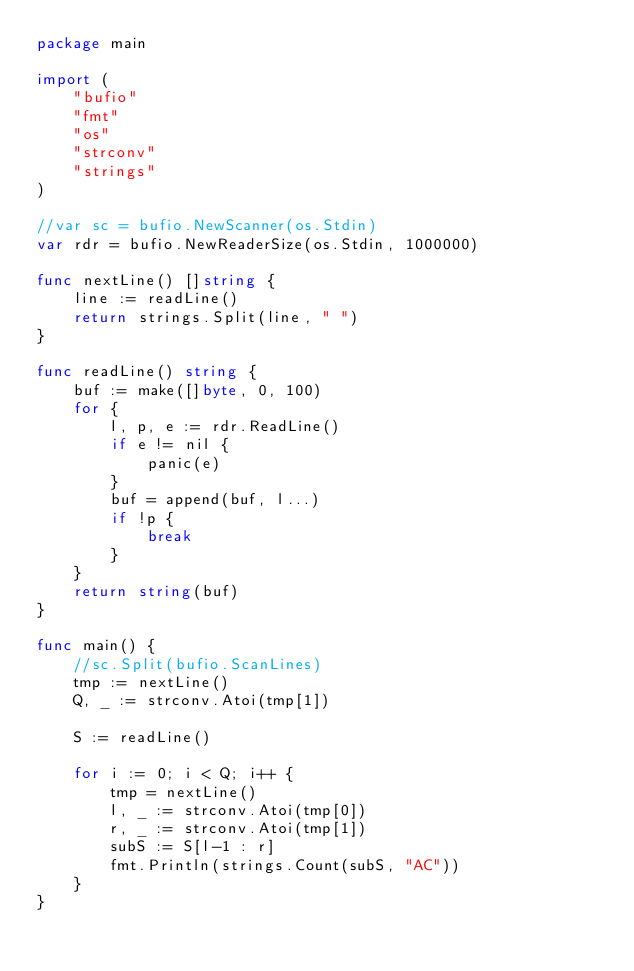<code> <loc_0><loc_0><loc_500><loc_500><_Go_>package main

import (
	"bufio"
	"fmt"
	"os"
	"strconv"
	"strings"
)

//var sc = bufio.NewScanner(os.Stdin)
var rdr = bufio.NewReaderSize(os.Stdin, 1000000)

func nextLine() []string {
	line := readLine()
	return strings.Split(line, " ")
}

func readLine() string {
	buf := make([]byte, 0, 100)
	for {
		l, p, e := rdr.ReadLine()
		if e != nil {
			panic(e)
		}
		buf = append(buf, l...)
		if !p {
			break
		}
	}
	return string(buf)
}

func main() {
	//sc.Split(bufio.ScanLines)
	tmp := nextLine()
	Q, _ := strconv.Atoi(tmp[1])

	S := readLine()

	for i := 0; i < Q; i++ {
		tmp = nextLine()
		l, _ := strconv.Atoi(tmp[0])
		r, _ := strconv.Atoi(tmp[1])
		subS := S[l-1 : r]
		fmt.Println(strings.Count(subS, "AC"))
	}
}</code> 